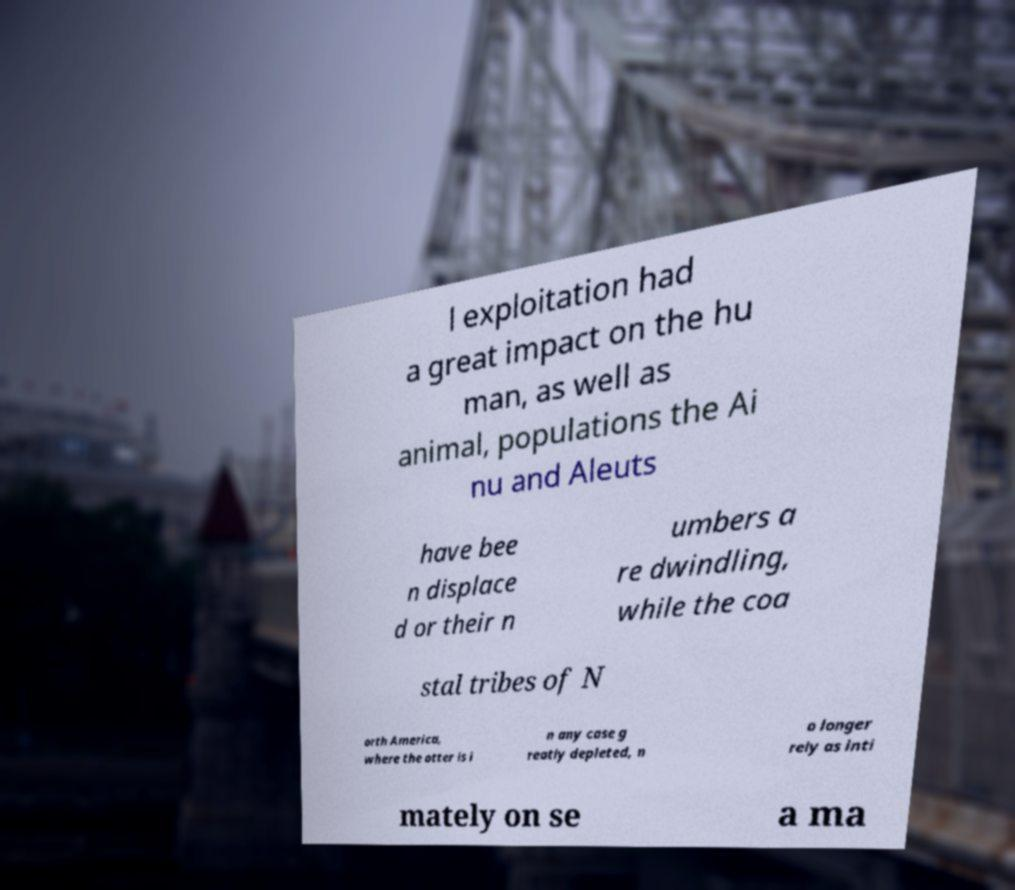What messages or text are displayed in this image? I need them in a readable, typed format. l exploitation had a great impact on the hu man, as well as animal, populations the Ai nu and Aleuts have bee n displace d or their n umbers a re dwindling, while the coa stal tribes of N orth America, where the otter is i n any case g reatly depleted, n o longer rely as inti mately on se a ma 